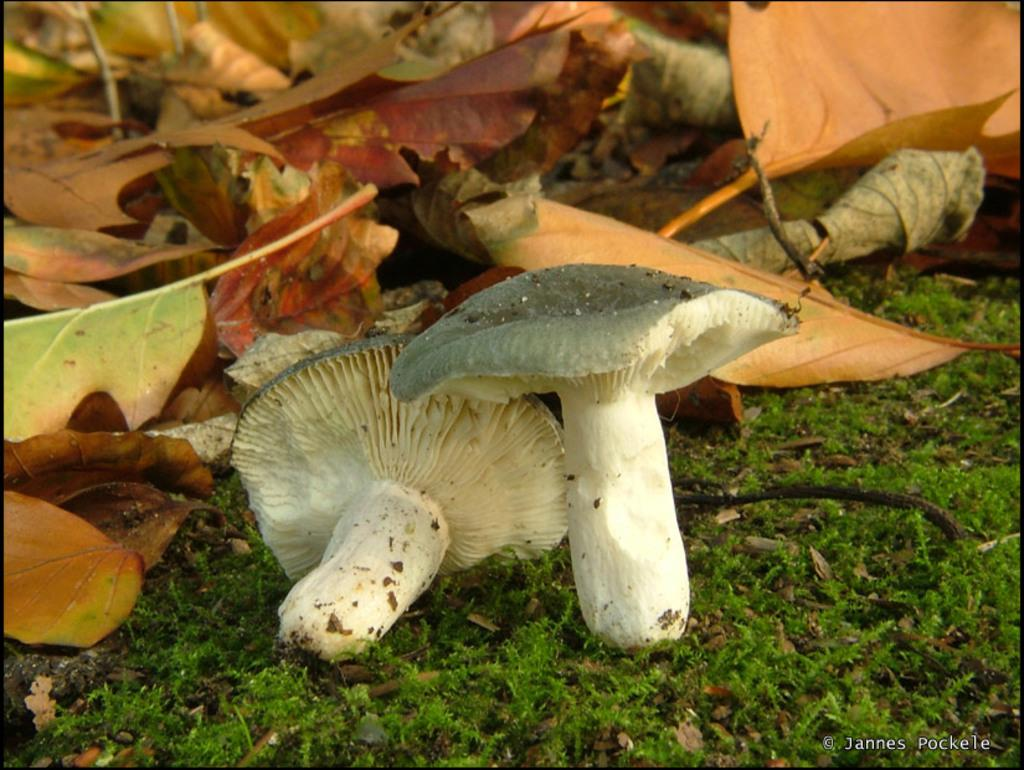What type of vegetation is at the bottom of the image? There is grass at the bottom of the image. What can be seen in the foreground of the image? There are mushrooms in the foreground of the image. What type of vegetation is in the background of the image? There are leaves in the background of the image. What type of rice is being used in the class depicted in the image? There is no class or rice present in the image; it features grass, mushrooms, and leaves. How does the comb help in the image? There is no comb present in the image. 